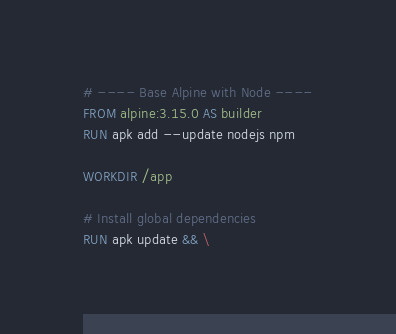<code> <loc_0><loc_0><loc_500><loc_500><_Dockerfile_># ---- Base Alpine with Node ----
FROM alpine:3.15.0 AS builder
RUN apk add --update nodejs npm

WORKDIR /app

# Install global dependencies
RUN apk update && \</code> 